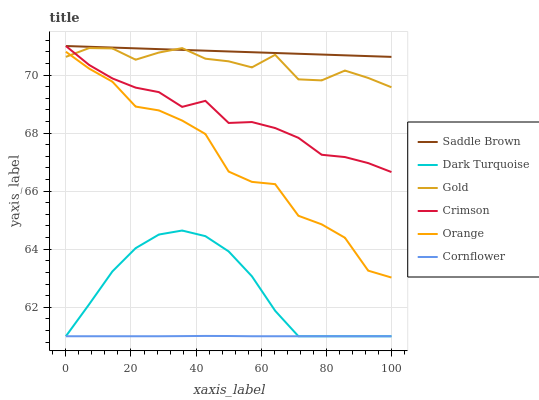Does Cornflower have the minimum area under the curve?
Answer yes or no. Yes. Does Saddle Brown have the maximum area under the curve?
Answer yes or no. Yes. Does Gold have the minimum area under the curve?
Answer yes or no. No. Does Gold have the maximum area under the curve?
Answer yes or no. No. Is Saddle Brown the smoothest?
Answer yes or no. Yes. Is Orange the roughest?
Answer yes or no. Yes. Is Gold the smoothest?
Answer yes or no. No. Is Gold the roughest?
Answer yes or no. No. Does Cornflower have the lowest value?
Answer yes or no. Yes. Does Gold have the lowest value?
Answer yes or no. No. Does Saddle Brown have the highest value?
Answer yes or no. Yes. Does Gold have the highest value?
Answer yes or no. No. Is Cornflower less than Crimson?
Answer yes or no. Yes. Is Saddle Brown greater than Orange?
Answer yes or no. Yes. Does Orange intersect Gold?
Answer yes or no. Yes. Is Orange less than Gold?
Answer yes or no. No. Is Orange greater than Gold?
Answer yes or no. No. Does Cornflower intersect Crimson?
Answer yes or no. No. 